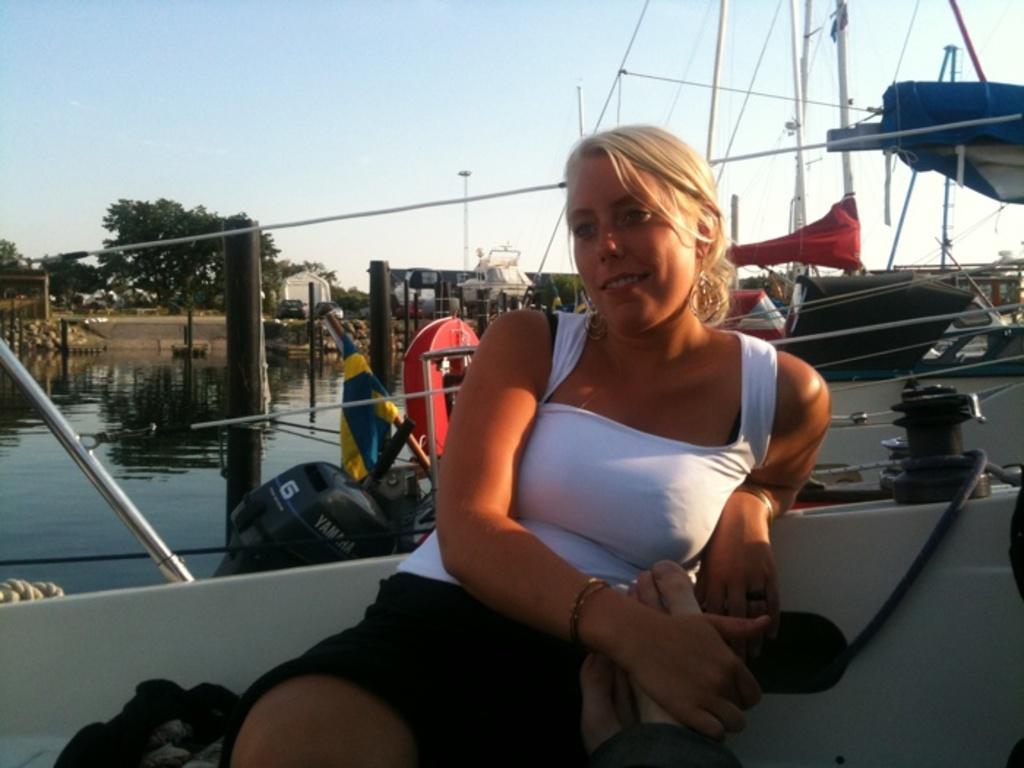Describe this image in one or two sentences. In the foreground I can see a woman in the boat. In the background I can see boats in the water, trees, houses and the sky. This image is taken may be during a sunny day. 